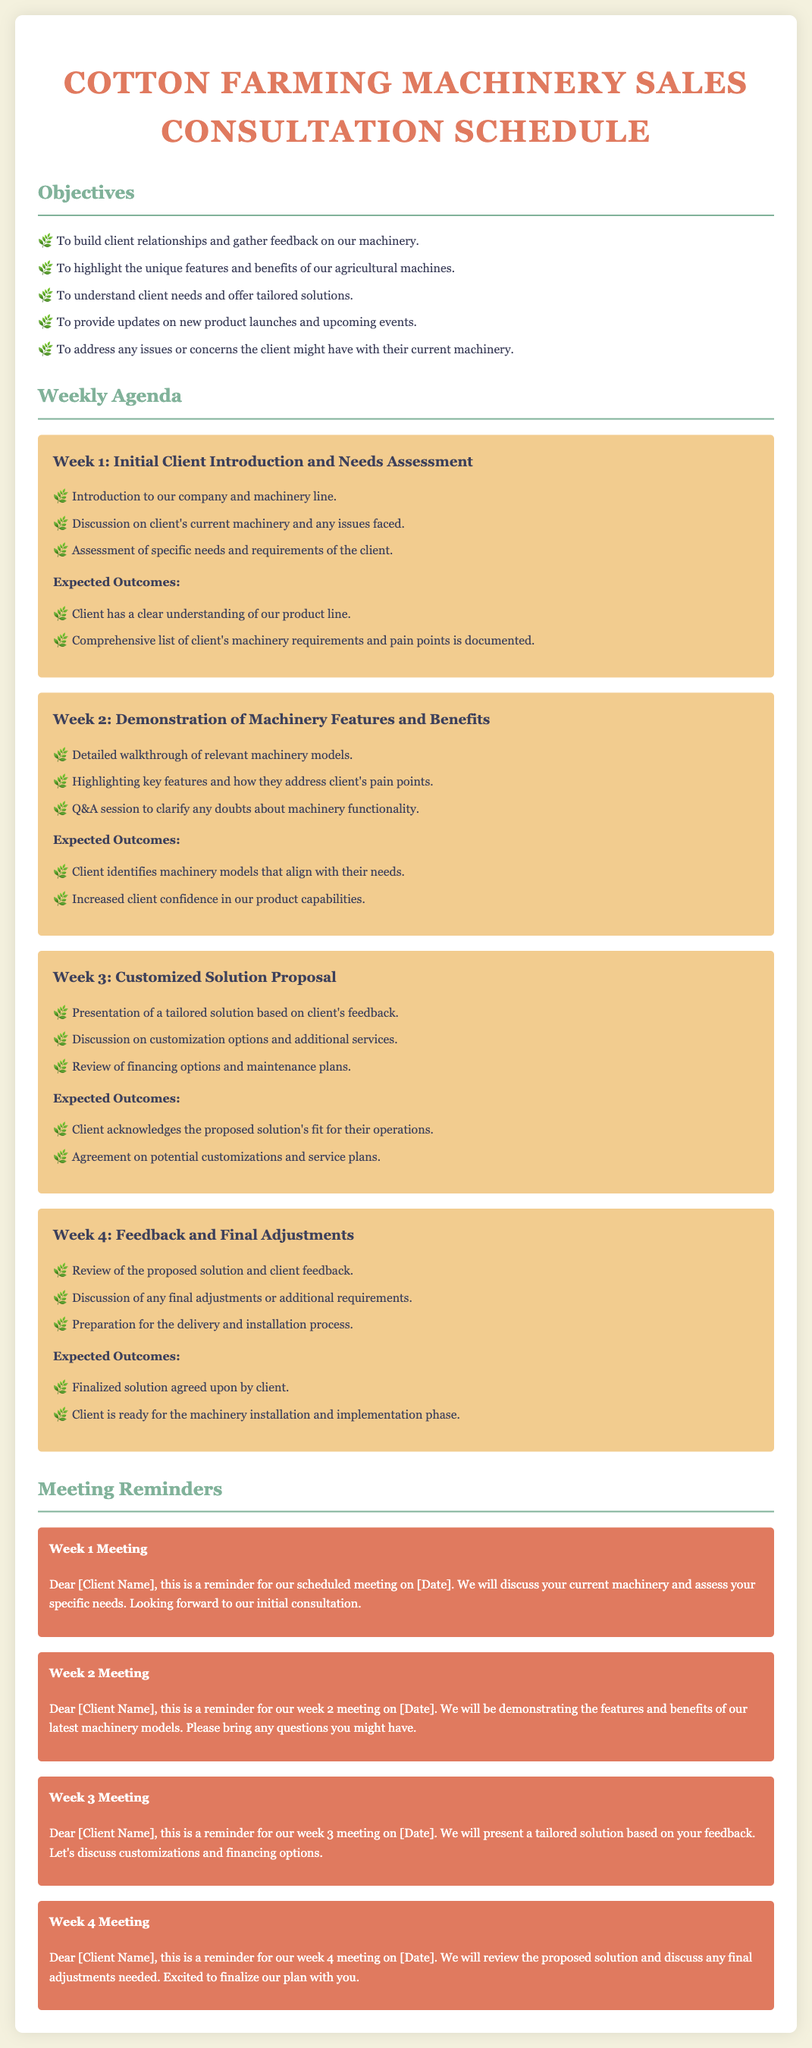what is the main objective of the consultation? The main objective is to build client relationships and gather feedback on our machinery.
Answer: build client relationships and gather feedback on our machinery how many weeks are covered in this consultation schedule? The consultation schedule covers four weeks, as outlined in the weekly agenda.
Answer: four weeks what is discussed in Week 2? Week 2 covers the demonstration of machinery features and benefits, along with a Q&A session.
Answer: demonstration of machinery features and benefits what is expected outcome from Week 3? An expected outcome from Week 3 is the agreement on potential customizations and service plans.
Answer: agreement on potential customizations and service plans when is the Week 1 meeting reminder sent? The reminder for Week 1 is for the scheduled meeting on the date indicated in the document.
Answer: on [Date] 